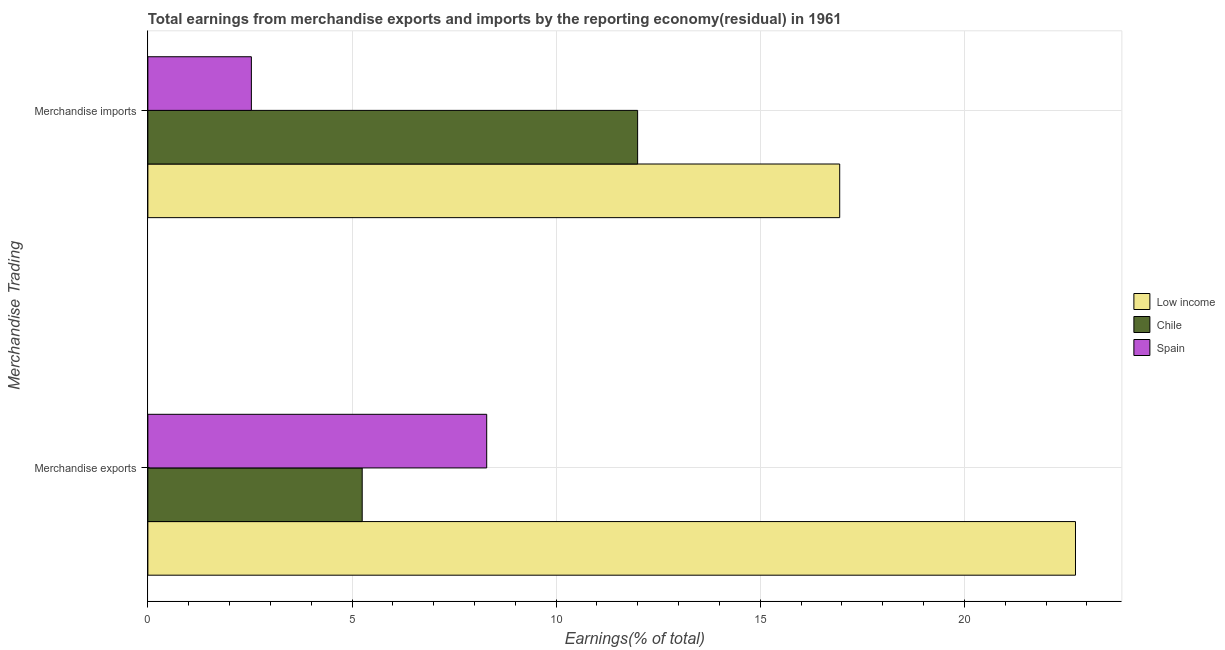How many groups of bars are there?
Provide a short and direct response. 2. How many bars are there on the 1st tick from the bottom?
Your response must be concise. 3. What is the earnings from merchandise exports in Chile?
Provide a succinct answer. 5.25. Across all countries, what is the maximum earnings from merchandise exports?
Offer a terse response. 22.72. Across all countries, what is the minimum earnings from merchandise exports?
Keep it short and to the point. 5.25. In which country was the earnings from merchandise exports maximum?
Ensure brevity in your answer.  Low income. What is the total earnings from merchandise imports in the graph?
Give a very brief answer. 31.48. What is the difference between the earnings from merchandise imports in Chile and that in Low income?
Keep it short and to the point. -4.95. What is the difference between the earnings from merchandise imports in Spain and the earnings from merchandise exports in Chile?
Your answer should be very brief. -2.71. What is the average earnings from merchandise exports per country?
Make the answer very short. 12.09. What is the difference between the earnings from merchandise imports and earnings from merchandise exports in Low income?
Keep it short and to the point. -5.77. In how many countries, is the earnings from merchandise imports greater than 4 %?
Your answer should be compact. 2. What is the ratio of the earnings from merchandise imports in Chile to that in Spain?
Offer a very short reply. 4.73. In how many countries, is the earnings from merchandise imports greater than the average earnings from merchandise imports taken over all countries?
Provide a succinct answer. 2. What does the 3rd bar from the top in Merchandise exports represents?
Offer a terse response. Low income. What does the 1st bar from the bottom in Merchandise exports represents?
Ensure brevity in your answer.  Low income. How many countries are there in the graph?
Your response must be concise. 3. Are the values on the major ticks of X-axis written in scientific E-notation?
Your answer should be compact. No. Does the graph contain any zero values?
Your response must be concise. No. How many legend labels are there?
Ensure brevity in your answer.  3. How are the legend labels stacked?
Offer a terse response. Vertical. What is the title of the graph?
Provide a short and direct response. Total earnings from merchandise exports and imports by the reporting economy(residual) in 1961. What is the label or title of the X-axis?
Provide a succinct answer. Earnings(% of total). What is the label or title of the Y-axis?
Offer a very short reply. Merchandise Trading. What is the Earnings(% of total) in Low income in Merchandise exports?
Offer a terse response. 22.72. What is the Earnings(% of total) in Chile in Merchandise exports?
Ensure brevity in your answer.  5.25. What is the Earnings(% of total) of Spain in Merchandise exports?
Keep it short and to the point. 8.3. What is the Earnings(% of total) in Low income in Merchandise imports?
Provide a short and direct response. 16.95. What is the Earnings(% of total) in Chile in Merchandise imports?
Offer a very short reply. 12. What is the Earnings(% of total) in Spain in Merchandise imports?
Give a very brief answer. 2.54. Across all Merchandise Trading, what is the maximum Earnings(% of total) of Low income?
Keep it short and to the point. 22.72. Across all Merchandise Trading, what is the maximum Earnings(% of total) in Chile?
Offer a terse response. 12. Across all Merchandise Trading, what is the maximum Earnings(% of total) of Spain?
Ensure brevity in your answer.  8.3. Across all Merchandise Trading, what is the minimum Earnings(% of total) of Low income?
Your answer should be very brief. 16.95. Across all Merchandise Trading, what is the minimum Earnings(% of total) in Chile?
Give a very brief answer. 5.25. Across all Merchandise Trading, what is the minimum Earnings(% of total) in Spain?
Offer a very short reply. 2.54. What is the total Earnings(% of total) of Low income in the graph?
Offer a very short reply. 39.67. What is the total Earnings(% of total) in Chile in the graph?
Offer a terse response. 17.25. What is the total Earnings(% of total) of Spain in the graph?
Keep it short and to the point. 10.83. What is the difference between the Earnings(% of total) of Low income in Merchandise exports and that in Merchandise imports?
Keep it short and to the point. 5.78. What is the difference between the Earnings(% of total) in Chile in Merchandise exports and that in Merchandise imports?
Your answer should be compact. -6.75. What is the difference between the Earnings(% of total) in Spain in Merchandise exports and that in Merchandise imports?
Your answer should be compact. 5.76. What is the difference between the Earnings(% of total) in Low income in Merchandise exports and the Earnings(% of total) in Chile in Merchandise imports?
Keep it short and to the point. 10.72. What is the difference between the Earnings(% of total) of Low income in Merchandise exports and the Earnings(% of total) of Spain in Merchandise imports?
Your answer should be very brief. 20.19. What is the difference between the Earnings(% of total) in Chile in Merchandise exports and the Earnings(% of total) in Spain in Merchandise imports?
Keep it short and to the point. 2.71. What is the average Earnings(% of total) in Low income per Merchandise Trading?
Provide a succinct answer. 19.83. What is the average Earnings(% of total) of Chile per Merchandise Trading?
Offer a very short reply. 8.62. What is the average Earnings(% of total) in Spain per Merchandise Trading?
Your answer should be compact. 5.42. What is the difference between the Earnings(% of total) of Low income and Earnings(% of total) of Chile in Merchandise exports?
Provide a short and direct response. 17.47. What is the difference between the Earnings(% of total) in Low income and Earnings(% of total) in Spain in Merchandise exports?
Your response must be concise. 14.42. What is the difference between the Earnings(% of total) in Chile and Earnings(% of total) in Spain in Merchandise exports?
Provide a succinct answer. -3.05. What is the difference between the Earnings(% of total) in Low income and Earnings(% of total) in Chile in Merchandise imports?
Give a very brief answer. 4.95. What is the difference between the Earnings(% of total) of Low income and Earnings(% of total) of Spain in Merchandise imports?
Offer a terse response. 14.41. What is the difference between the Earnings(% of total) in Chile and Earnings(% of total) in Spain in Merchandise imports?
Your answer should be very brief. 9.46. What is the ratio of the Earnings(% of total) of Low income in Merchandise exports to that in Merchandise imports?
Offer a terse response. 1.34. What is the ratio of the Earnings(% of total) of Chile in Merchandise exports to that in Merchandise imports?
Your answer should be compact. 0.44. What is the ratio of the Earnings(% of total) in Spain in Merchandise exports to that in Merchandise imports?
Give a very brief answer. 3.27. What is the difference between the highest and the second highest Earnings(% of total) of Low income?
Provide a succinct answer. 5.78. What is the difference between the highest and the second highest Earnings(% of total) of Chile?
Provide a short and direct response. 6.75. What is the difference between the highest and the second highest Earnings(% of total) of Spain?
Offer a terse response. 5.76. What is the difference between the highest and the lowest Earnings(% of total) in Low income?
Provide a short and direct response. 5.78. What is the difference between the highest and the lowest Earnings(% of total) in Chile?
Provide a succinct answer. 6.75. What is the difference between the highest and the lowest Earnings(% of total) of Spain?
Offer a terse response. 5.76. 